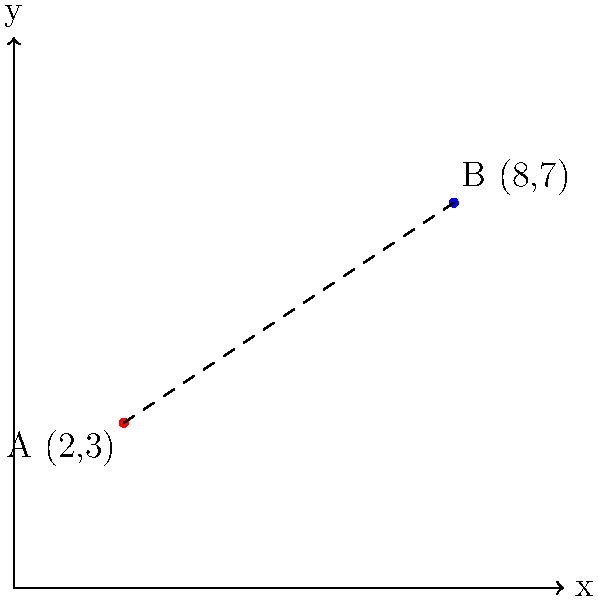As part of planning a youth field trip, you need to calculate the distance between two geographic landmarks. Landmark A is located at coordinates (2, 3) and Landmark B is at (8, 7) on a map grid where each unit represents 1 km. Using the distance formula, determine the straight-line distance between these two landmarks to the nearest tenth of a kilometer. To solve this problem, we'll use the distance formula derived from the Pythagorean theorem:

$$ d = \sqrt{(x_2 - x_1)^2 + (y_2 - y_1)^2} $$

Where $(x_1, y_1)$ are the coordinates of the first point and $(x_2, y_2)$ are the coordinates of the second point.

Step 1: Identify the coordinates
- Landmark A: $(x_1, y_1) = (2, 3)$
- Landmark B: $(x_2, y_2) = (8, 7)$

Step 2: Plug the coordinates into the distance formula
$$ d = \sqrt{(8 - 2)^2 + (7 - 3)^2} $$

Step 3: Simplify the expressions inside the parentheses
$$ d = \sqrt{6^2 + 4^2} $$

Step 4: Calculate the squares
$$ d = \sqrt{36 + 16} $$

Step 5: Add the numbers under the square root
$$ d = \sqrt{52} $$

Step 6: Calculate the square root and round to the nearest tenth
$$ d \approx 7.2 $$

Therefore, the distance between Landmark A and Landmark B is approximately 7.2 km.
Answer: 7.2 km 